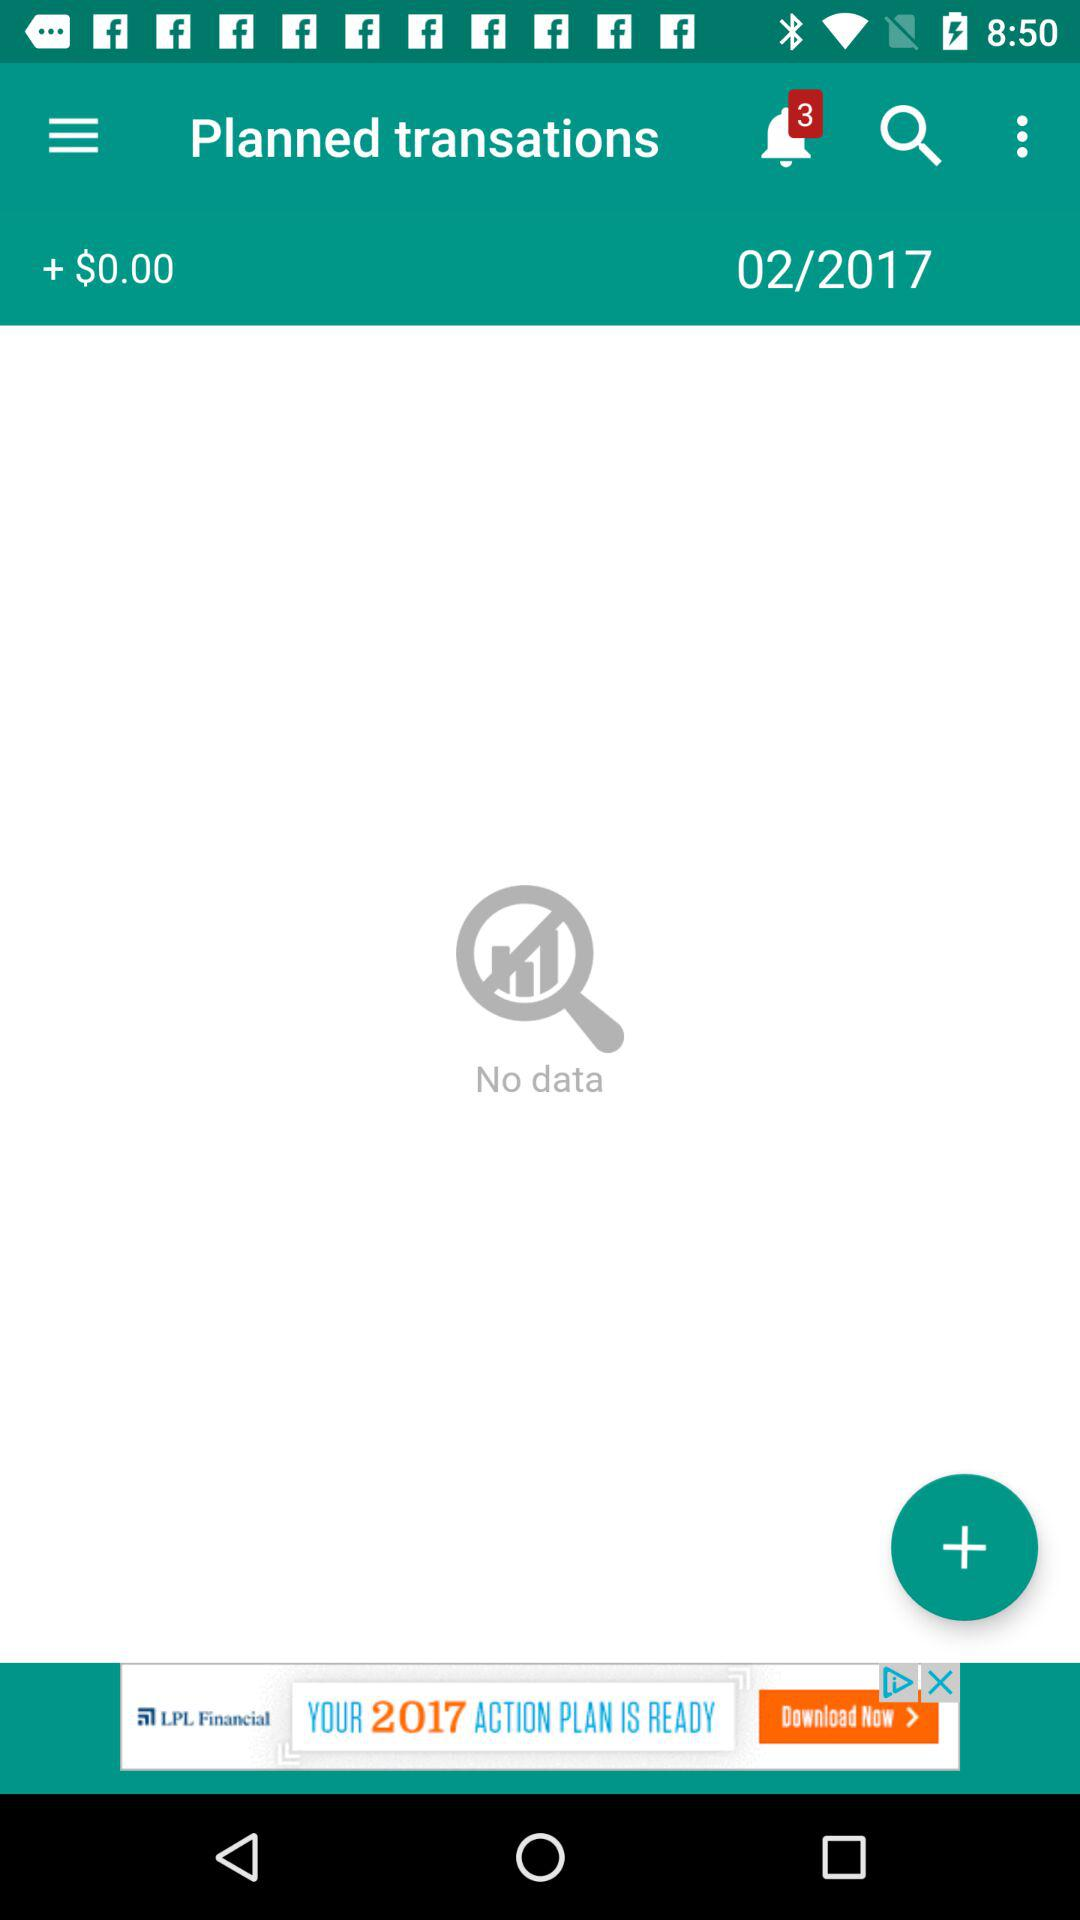How much is the total amount of money?
Answer the question using a single word or phrase. $0.00 